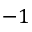Convert formula to latex. <formula><loc_0><loc_0><loc_500><loc_500>- 1</formula> 